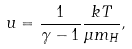Convert formula to latex. <formula><loc_0><loc_0><loc_500><loc_500>u = \frac { 1 } { \gamma - 1 } \frac { k T } { \mu m _ { H } } ,</formula> 